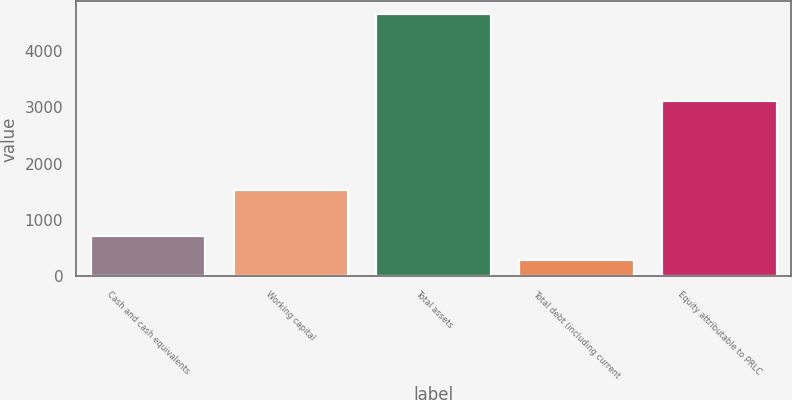Convert chart. <chart><loc_0><loc_0><loc_500><loc_500><bar_chart><fcel>Cash and cash equivalents<fcel>Working capital<fcel>Total assets<fcel>Total debt (including current<fcel>Equity attributable to PRLC<nl><fcel>718.78<fcel>1528.5<fcel>4648.9<fcel>282.1<fcel>3116.6<nl></chart> 